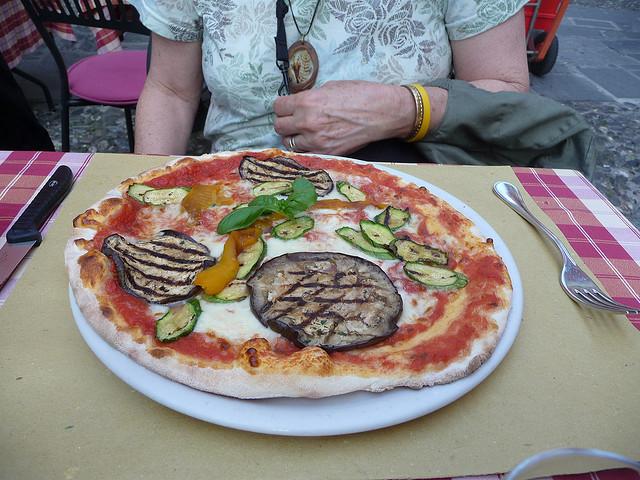What is on the plate?
Be succinct. Pizza. Is the person a woman or a man?
Write a very short answer. Woman. Is this a normal looking pizza?
Be succinct. No. 